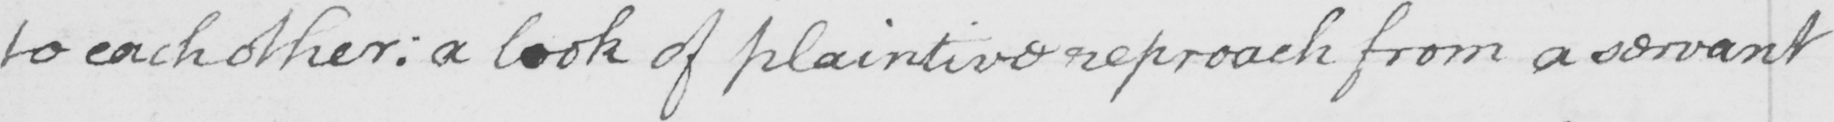What is written in this line of handwriting? to each other :  a look of plaintive reproach from a servant 